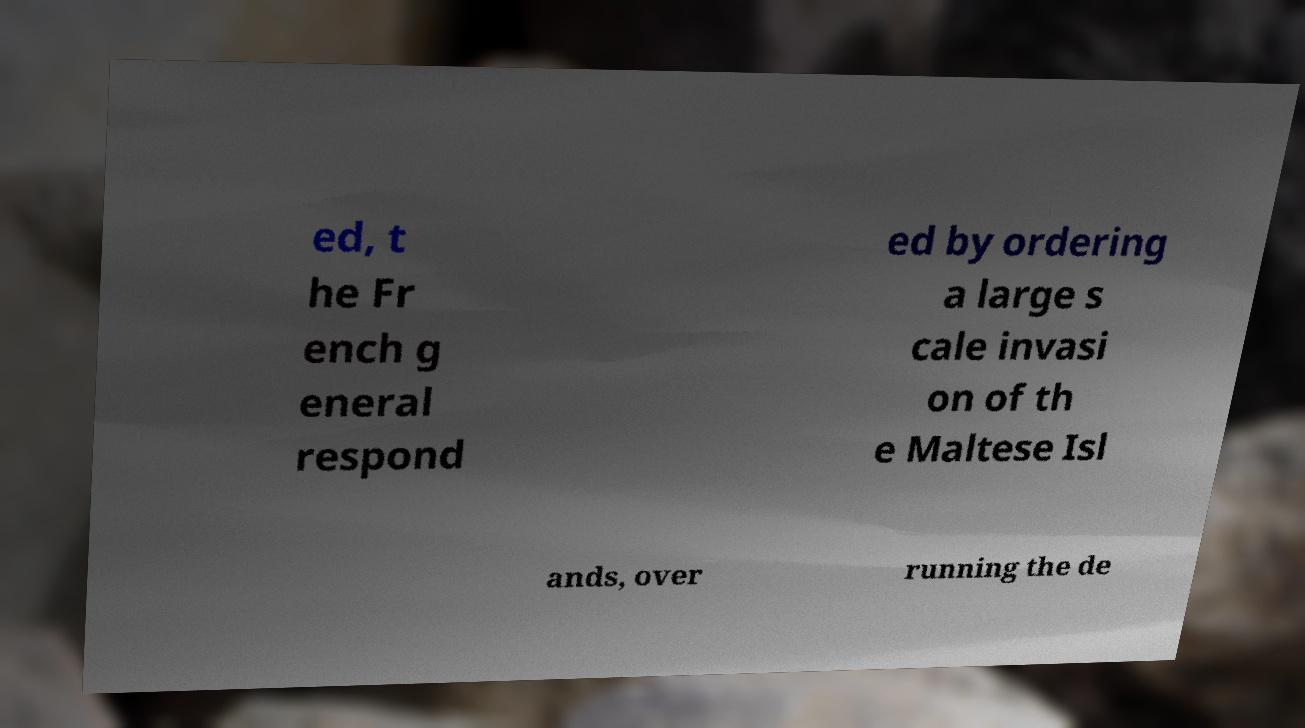Could you assist in decoding the text presented in this image and type it out clearly? ed, t he Fr ench g eneral respond ed by ordering a large s cale invasi on of th e Maltese Isl ands, over running the de 